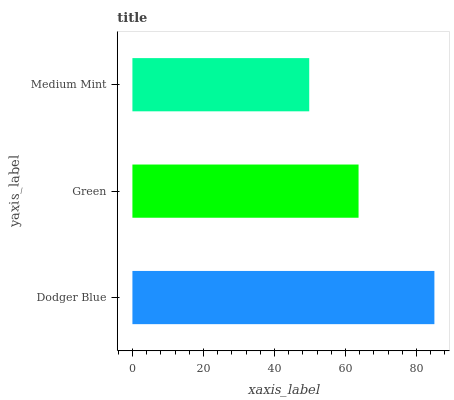Is Medium Mint the minimum?
Answer yes or no. Yes. Is Dodger Blue the maximum?
Answer yes or no. Yes. Is Green the minimum?
Answer yes or no. No. Is Green the maximum?
Answer yes or no. No. Is Dodger Blue greater than Green?
Answer yes or no. Yes. Is Green less than Dodger Blue?
Answer yes or no. Yes. Is Green greater than Dodger Blue?
Answer yes or no. No. Is Dodger Blue less than Green?
Answer yes or no. No. Is Green the high median?
Answer yes or no. Yes. Is Green the low median?
Answer yes or no. Yes. Is Dodger Blue the high median?
Answer yes or no. No. Is Medium Mint the low median?
Answer yes or no. No. 